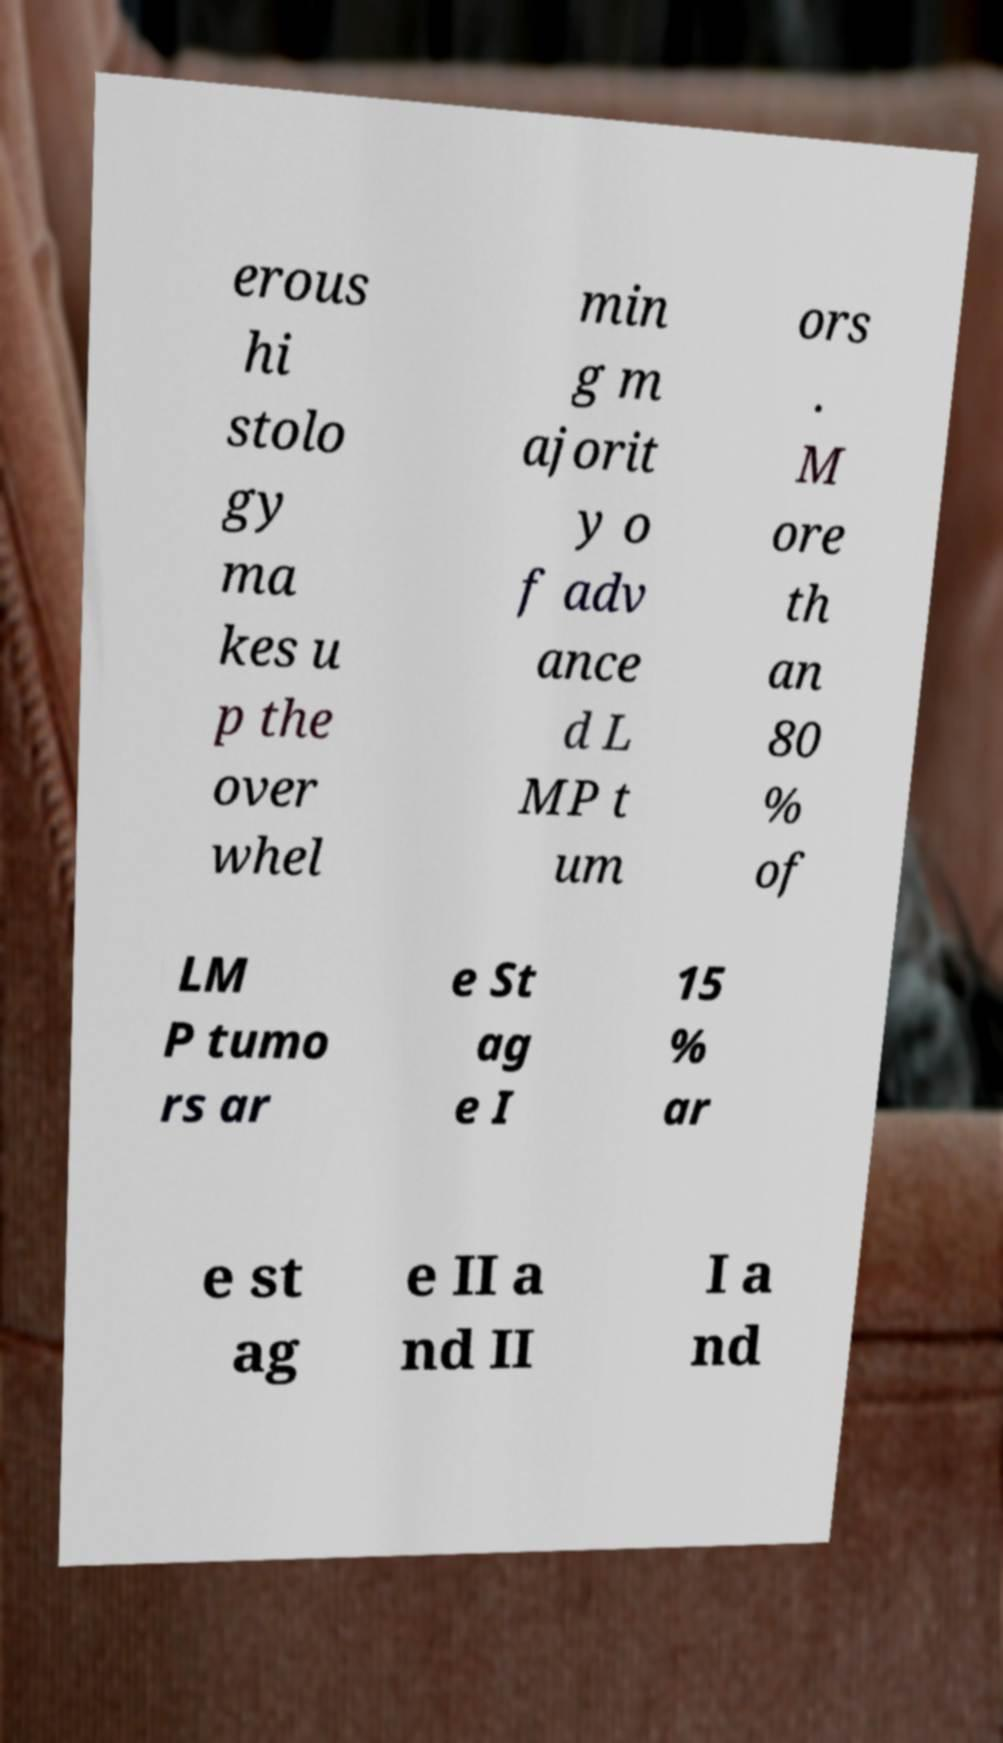For documentation purposes, I need the text within this image transcribed. Could you provide that? erous hi stolo gy ma kes u p the over whel min g m ajorit y o f adv ance d L MP t um ors . M ore th an 80 % of LM P tumo rs ar e St ag e I 15 % ar e st ag e II a nd II I a nd 